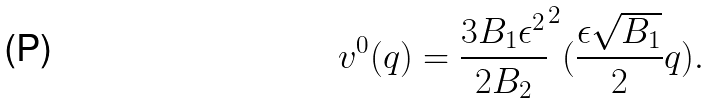Convert formula to latex. <formula><loc_0><loc_0><loc_500><loc_500>v ^ { 0 } ( q ) = \frac { 3 B _ { 1 } \epsilon ^ { 2 } } { 2 B _ { 2 } } ^ { 2 } ( \frac { \epsilon \sqrt { B _ { 1 } } } { 2 } q ) .</formula> 